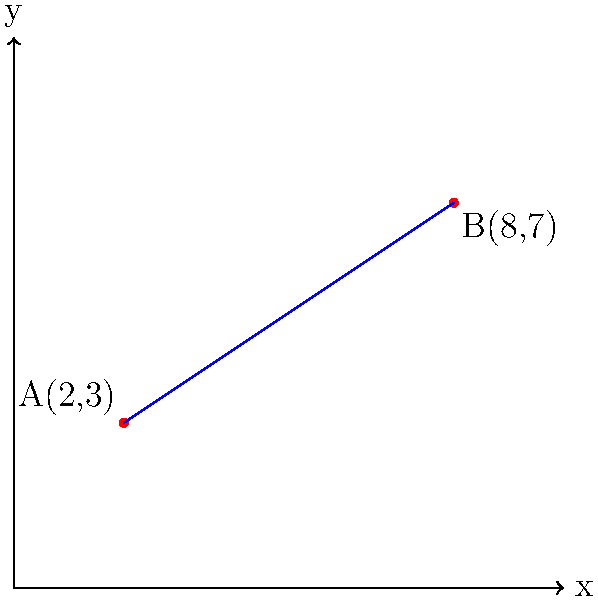In an image processing task, you've identified two feature points: A(2,3) and B(8,7). Calculate the slope of the line connecting these two points. How would this slope information be useful in determining the orientation of an object in the image? To solve this problem, we'll follow these steps:

1) Recall the slope formula:
   $$ m = \frac{y_2 - y_1}{x_2 - x_1} $$
   where $(x_1, y_1)$ and $(x_2, y_2)$ are the coordinates of two points on the line.

2) We have:
   Point A: $(x_1, y_1) = (2, 3)$
   Point B: $(x_2, y_2) = (8, 7)$

3) Substituting into the formula:
   $$ m = \frac{7 - 3}{8 - 2} = \frac{4}{6} $$

4) Simplify:
   $$ m = \frac{2}{3} \approx 0.667 $$

The slope of 2/3 indicates that for every 3 units the line moves horizontally, it rises 2 units vertically.

In image processing and object recognition:
- The slope provides information about the orientation of the object or feature in the image.
- A slope of 2/3 suggests the object is tilted at an angle of approximately 33.7 degrees (arctan(2/3)) from the horizontal.
- This information can be crucial for tasks such as:
  a) Object alignment or rotation correction
  b) Feature matching between images
  c) Determining object pose or orientation in 3D reconstruction tasks

In a Ruby on Rails application, this calculation could be part of an image processing pipeline, potentially using libraries like ImageMagick or OpenCV via Ruby bindings.
Answer: $\frac{2}{3}$ 